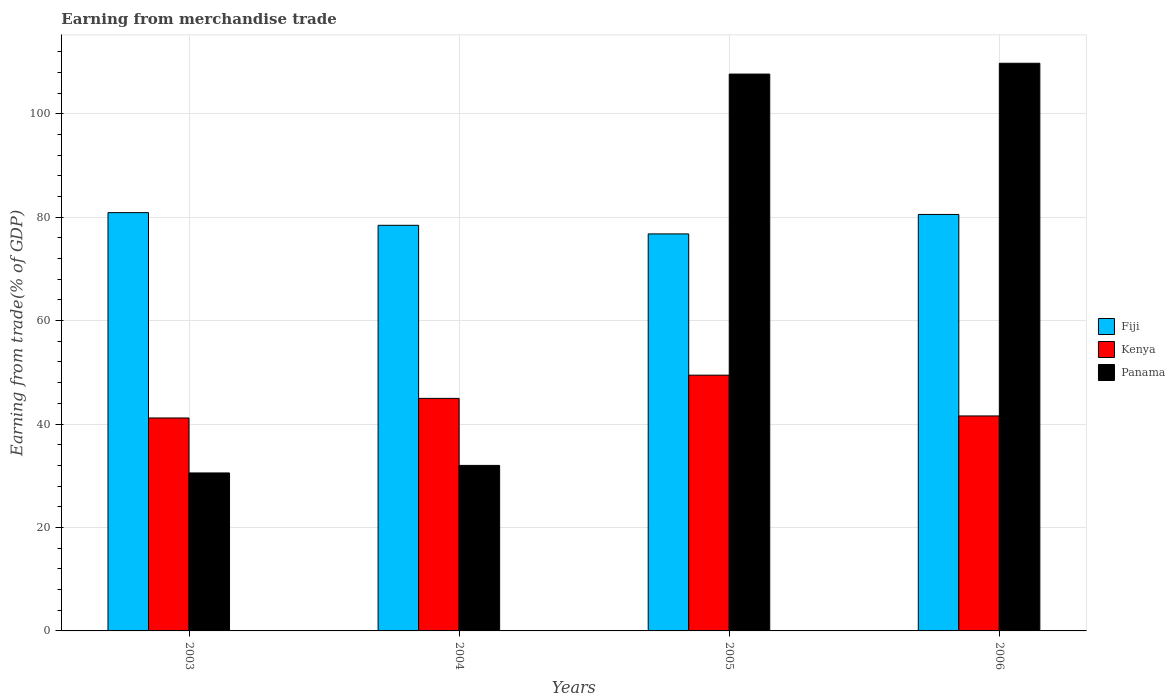How many different coloured bars are there?
Offer a terse response. 3. Are the number of bars on each tick of the X-axis equal?
Provide a short and direct response. Yes. How many bars are there on the 3rd tick from the right?
Give a very brief answer. 3. What is the label of the 2nd group of bars from the left?
Offer a terse response. 2004. What is the earnings from trade in Fiji in 2004?
Provide a succinct answer. 78.42. Across all years, what is the maximum earnings from trade in Kenya?
Your response must be concise. 49.45. Across all years, what is the minimum earnings from trade in Panama?
Provide a succinct answer. 30.54. What is the total earnings from trade in Panama in the graph?
Make the answer very short. 279.97. What is the difference between the earnings from trade in Fiji in 2003 and that in 2005?
Offer a terse response. 4.11. What is the difference between the earnings from trade in Fiji in 2005 and the earnings from trade in Kenya in 2004?
Ensure brevity in your answer.  31.8. What is the average earnings from trade in Kenya per year?
Ensure brevity in your answer.  44.29. In the year 2006, what is the difference between the earnings from trade in Fiji and earnings from trade in Kenya?
Offer a very short reply. 38.96. What is the ratio of the earnings from trade in Panama in 2003 to that in 2004?
Your answer should be compact. 0.95. Is the earnings from trade in Panama in 2004 less than that in 2006?
Keep it short and to the point. Yes. What is the difference between the highest and the second highest earnings from trade in Fiji?
Your answer should be compact. 0.35. What is the difference between the highest and the lowest earnings from trade in Kenya?
Ensure brevity in your answer.  8.28. In how many years, is the earnings from trade in Fiji greater than the average earnings from trade in Fiji taken over all years?
Provide a succinct answer. 2. What does the 1st bar from the left in 2006 represents?
Your response must be concise. Fiji. What does the 3rd bar from the right in 2003 represents?
Your answer should be very brief. Fiji. How many bars are there?
Your answer should be very brief. 12. Are all the bars in the graph horizontal?
Ensure brevity in your answer.  No. Are the values on the major ticks of Y-axis written in scientific E-notation?
Give a very brief answer. No. Does the graph contain grids?
Provide a short and direct response. Yes. Where does the legend appear in the graph?
Offer a terse response. Center right. How are the legend labels stacked?
Give a very brief answer. Vertical. What is the title of the graph?
Keep it short and to the point. Earning from merchandise trade. What is the label or title of the Y-axis?
Make the answer very short. Earning from trade(% of GDP). What is the Earning from trade(% of GDP) in Fiji in 2003?
Provide a succinct answer. 80.87. What is the Earning from trade(% of GDP) in Kenya in 2003?
Offer a terse response. 41.17. What is the Earning from trade(% of GDP) in Panama in 2003?
Ensure brevity in your answer.  30.54. What is the Earning from trade(% of GDP) in Fiji in 2004?
Provide a succinct answer. 78.42. What is the Earning from trade(% of GDP) of Kenya in 2004?
Your answer should be compact. 44.96. What is the Earning from trade(% of GDP) of Panama in 2004?
Give a very brief answer. 32. What is the Earning from trade(% of GDP) in Fiji in 2005?
Provide a short and direct response. 76.76. What is the Earning from trade(% of GDP) in Kenya in 2005?
Offer a very short reply. 49.45. What is the Earning from trade(% of GDP) of Panama in 2005?
Your answer should be compact. 107.66. What is the Earning from trade(% of GDP) in Fiji in 2006?
Give a very brief answer. 80.52. What is the Earning from trade(% of GDP) of Kenya in 2006?
Your answer should be very brief. 41.57. What is the Earning from trade(% of GDP) of Panama in 2006?
Offer a very short reply. 109.76. Across all years, what is the maximum Earning from trade(% of GDP) of Fiji?
Your response must be concise. 80.87. Across all years, what is the maximum Earning from trade(% of GDP) in Kenya?
Ensure brevity in your answer.  49.45. Across all years, what is the maximum Earning from trade(% of GDP) in Panama?
Give a very brief answer. 109.76. Across all years, what is the minimum Earning from trade(% of GDP) in Fiji?
Provide a succinct answer. 76.76. Across all years, what is the minimum Earning from trade(% of GDP) in Kenya?
Offer a very short reply. 41.17. Across all years, what is the minimum Earning from trade(% of GDP) of Panama?
Offer a very short reply. 30.54. What is the total Earning from trade(% of GDP) in Fiji in the graph?
Give a very brief answer. 316.58. What is the total Earning from trade(% of GDP) of Kenya in the graph?
Your response must be concise. 177.15. What is the total Earning from trade(% of GDP) in Panama in the graph?
Offer a very short reply. 279.97. What is the difference between the Earning from trade(% of GDP) in Fiji in 2003 and that in 2004?
Provide a succinct answer. 2.45. What is the difference between the Earning from trade(% of GDP) in Kenya in 2003 and that in 2004?
Offer a terse response. -3.79. What is the difference between the Earning from trade(% of GDP) of Panama in 2003 and that in 2004?
Make the answer very short. -1.46. What is the difference between the Earning from trade(% of GDP) of Fiji in 2003 and that in 2005?
Provide a succinct answer. 4.11. What is the difference between the Earning from trade(% of GDP) in Kenya in 2003 and that in 2005?
Your response must be concise. -8.28. What is the difference between the Earning from trade(% of GDP) of Panama in 2003 and that in 2005?
Give a very brief answer. -77.12. What is the difference between the Earning from trade(% of GDP) in Fiji in 2003 and that in 2006?
Provide a short and direct response. 0.35. What is the difference between the Earning from trade(% of GDP) of Kenya in 2003 and that in 2006?
Ensure brevity in your answer.  -0.39. What is the difference between the Earning from trade(% of GDP) of Panama in 2003 and that in 2006?
Provide a short and direct response. -79.21. What is the difference between the Earning from trade(% of GDP) of Fiji in 2004 and that in 2005?
Make the answer very short. 1.66. What is the difference between the Earning from trade(% of GDP) in Kenya in 2004 and that in 2005?
Your answer should be very brief. -4.49. What is the difference between the Earning from trade(% of GDP) in Panama in 2004 and that in 2005?
Give a very brief answer. -75.66. What is the difference between the Earning from trade(% of GDP) of Fiji in 2004 and that in 2006?
Offer a very short reply. -2.1. What is the difference between the Earning from trade(% of GDP) in Kenya in 2004 and that in 2006?
Offer a terse response. 3.4. What is the difference between the Earning from trade(% of GDP) in Panama in 2004 and that in 2006?
Provide a succinct answer. -77.75. What is the difference between the Earning from trade(% of GDP) in Fiji in 2005 and that in 2006?
Your answer should be compact. -3.76. What is the difference between the Earning from trade(% of GDP) of Kenya in 2005 and that in 2006?
Ensure brevity in your answer.  7.89. What is the difference between the Earning from trade(% of GDP) of Panama in 2005 and that in 2006?
Make the answer very short. -2.09. What is the difference between the Earning from trade(% of GDP) in Fiji in 2003 and the Earning from trade(% of GDP) in Kenya in 2004?
Ensure brevity in your answer.  35.91. What is the difference between the Earning from trade(% of GDP) in Fiji in 2003 and the Earning from trade(% of GDP) in Panama in 2004?
Your answer should be very brief. 48.87. What is the difference between the Earning from trade(% of GDP) in Kenya in 2003 and the Earning from trade(% of GDP) in Panama in 2004?
Your answer should be compact. 9.17. What is the difference between the Earning from trade(% of GDP) of Fiji in 2003 and the Earning from trade(% of GDP) of Kenya in 2005?
Provide a short and direct response. 31.42. What is the difference between the Earning from trade(% of GDP) of Fiji in 2003 and the Earning from trade(% of GDP) of Panama in 2005?
Keep it short and to the point. -26.79. What is the difference between the Earning from trade(% of GDP) in Kenya in 2003 and the Earning from trade(% of GDP) in Panama in 2005?
Make the answer very short. -66.49. What is the difference between the Earning from trade(% of GDP) of Fiji in 2003 and the Earning from trade(% of GDP) of Kenya in 2006?
Offer a terse response. 39.31. What is the difference between the Earning from trade(% of GDP) in Fiji in 2003 and the Earning from trade(% of GDP) in Panama in 2006?
Your answer should be compact. -28.88. What is the difference between the Earning from trade(% of GDP) in Kenya in 2003 and the Earning from trade(% of GDP) in Panama in 2006?
Provide a succinct answer. -68.58. What is the difference between the Earning from trade(% of GDP) in Fiji in 2004 and the Earning from trade(% of GDP) in Kenya in 2005?
Provide a succinct answer. 28.97. What is the difference between the Earning from trade(% of GDP) in Fiji in 2004 and the Earning from trade(% of GDP) in Panama in 2005?
Provide a short and direct response. -29.24. What is the difference between the Earning from trade(% of GDP) in Kenya in 2004 and the Earning from trade(% of GDP) in Panama in 2005?
Offer a very short reply. -62.7. What is the difference between the Earning from trade(% of GDP) in Fiji in 2004 and the Earning from trade(% of GDP) in Kenya in 2006?
Provide a short and direct response. 36.86. What is the difference between the Earning from trade(% of GDP) in Fiji in 2004 and the Earning from trade(% of GDP) in Panama in 2006?
Your answer should be very brief. -31.33. What is the difference between the Earning from trade(% of GDP) in Kenya in 2004 and the Earning from trade(% of GDP) in Panama in 2006?
Provide a short and direct response. -64.79. What is the difference between the Earning from trade(% of GDP) in Fiji in 2005 and the Earning from trade(% of GDP) in Kenya in 2006?
Your response must be concise. 35.2. What is the difference between the Earning from trade(% of GDP) of Fiji in 2005 and the Earning from trade(% of GDP) of Panama in 2006?
Keep it short and to the point. -32.99. What is the difference between the Earning from trade(% of GDP) of Kenya in 2005 and the Earning from trade(% of GDP) of Panama in 2006?
Your response must be concise. -60.3. What is the average Earning from trade(% of GDP) of Fiji per year?
Ensure brevity in your answer.  79.15. What is the average Earning from trade(% of GDP) in Kenya per year?
Ensure brevity in your answer.  44.29. What is the average Earning from trade(% of GDP) in Panama per year?
Ensure brevity in your answer.  69.99. In the year 2003, what is the difference between the Earning from trade(% of GDP) in Fiji and Earning from trade(% of GDP) in Kenya?
Give a very brief answer. 39.7. In the year 2003, what is the difference between the Earning from trade(% of GDP) of Fiji and Earning from trade(% of GDP) of Panama?
Provide a short and direct response. 50.33. In the year 2003, what is the difference between the Earning from trade(% of GDP) of Kenya and Earning from trade(% of GDP) of Panama?
Offer a very short reply. 10.63. In the year 2004, what is the difference between the Earning from trade(% of GDP) in Fiji and Earning from trade(% of GDP) in Kenya?
Ensure brevity in your answer.  33.46. In the year 2004, what is the difference between the Earning from trade(% of GDP) in Fiji and Earning from trade(% of GDP) in Panama?
Ensure brevity in your answer.  46.42. In the year 2004, what is the difference between the Earning from trade(% of GDP) in Kenya and Earning from trade(% of GDP) in Panama?
Provide a succinct answer. 12.96. In the year 2005, what is the difference between the Earning from trade(% of GDP) in Fiji and Earning from trade(% of GDP) in Kenya?
Provide a succinct answer. 27.31. In the year 2005, what is the difference between the Earning from trade(% of GDP) of Fiji and Earning from trade(% of GDP) of Panama?
Offer a very short reply. -30.9. In the year 2005, what is the difference between the Earning from trade(% of GDP) of Kenya and Earning from trade(% of GDP) of Panama?
Give a very brief answer. -58.21. In the year 2006, what is the difference between the Earning from trade(% of GDP) of Fiji and Earning from trade(% of GDP) of Kenya?
Offer a very short reply. 38.96. In the year 2006, what is the difference between the Earning from trade(% of GDP) in Fiji and Earning from trade(% of GDP) in Panama?
Offer a very short reply. -29.23. In the year 2006, what is the difference between the Earning from trade(% of GDP) in Kenya and Earning from trade(% of GDP) in Panama?
Provide a short and direct response. -68.19. What is the ratio of the Earning from trade(% of GDP) in Fiji in 2003 to that in 2004?
Offer a very short reply. 1.03. What is the ratio of the Earning from trade(% of GDP) of Kenya in 2003 to that in 2004?
Offer a very short reply. 0.92. What is the ratio of the Earning from trade(% of GDP) in Panama in 2003 to that in 2004?
Make the answer very short. 0.95. What is the ratio of the Earning from trade(% of GDP) of Fiji in 2003 to that in 2005?
Your answer should be compact. 1.05. What is the ratio of the Earning from trade(% of GDP) in Kenya in 2003 to that in 2005?
Your response must be concise. 0.83. What is the ratio of the Earning from trade(% of GDP) in Panama in 2003 to that in 2005?
Your response must be concise. 0.28. What is the ratio of the Earning from trade(% of GDP) of Fiji in 2003 to that in 2006?
Make the answer very short. 1. What is the ratio of the Earning from trade(% of GDP) of Kenya in 2003 to that in 2006?
Offer a terse response. 0.99. What is the ratio of the Earning from trade(% of GDP) in Panama in 2003 to that in 2006?
Your answer should be very brief. 0.28. What is the ratio of the Earning from trade(% of GDP) in Fiji in 2004 to that in 2005?
Make the answer very short. 1.02. What is the ratio of the Earning from trade(% of GDP) in Kenya in 2004 to that in 2005?
Keep it short and to the point. 0.91. What is the ratio of the Earning from trade(% of GDP) in Panama in 2004 to that in 2005?
Make the answer very short. 0.3. What is the ratio of the Earning from trade(% of GDP) in Fiji in 2004 to that in 2006?
Your response must be concise. 0.97. What is the ratio of the Earning from trade(% of GDP) of Kenya in 2004 to that in 2006?
Your answer should be compact. 1.08. What is the ratio of the Earning from trade(% of GDP) in Panama in 2004 to that in 2006?
Your answer should be compact. 0.29. What is the ratio of the Earning from trade(% of GDP) of Fiji in 2005 to that in 2006?
Provide a short and direct response. 0.95. What is the ratio of the Earning from trade(% of GDP) of Kenya in 2005 to that in 2006?
Your answer should be compact. 1.19. What is the ratio of the Earning from trade(% of GDP) of Panama in 2005 to that in 2006?
Ensure brevity in your answer.  0.98. What is the difference between the highest and the second highest Earning from trade(% of GDP) of Fiji?
Offer a terse response. 0.35. What is the difference between the highest and the second highest Earning from trade(% of GDP) in Kenya?
Make the answer very short. 4.49. What is the difference between the highest and the second highest Earning from trade(% of GDP) in Panama?
Provide a succinct answer. 2.09. What is the difference between the highest and the lowest Earning from trade(% of GDP) in Fiji?
Provide a short and direct response. 4.11. What is the difference between the highest and the lowest Earning from trade(% of GDP) in Kenya?
Ensure brevity in your answer.  8.28. What is the difference between the highest and the lowest Earning from trade(% of GDP) of Panama?
Provide a succinct answer. 79.21. 